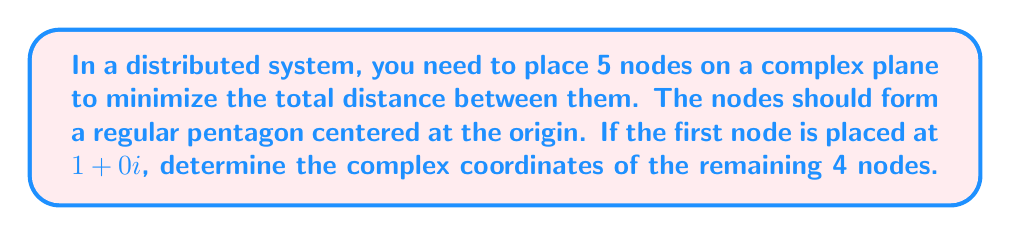Solve this math problem. To solve this problem, we'll use complex number-based optimization techniques:

1) In a regular pentagon, the angle between any two adjacent vertices from the center is $\frac{2\pi}{5}$ radians.

2) We can represent rotations in the complex plane using the formula:
   $$z_n = z_1 \cdot e^{i\frac{2\pi n}{5}}$$
   where $z_1$ is the first node, and $n$ is the node number (0 to 4).

3) Given $z_1 = 1+0i$, we can calculate the remaining nodes:

   For $n = 1$ (already given): $z_1 = 1+0i$
   
   For $n = 2$: $z_2 = (1+0i) \cdot e^{i\frac{2\pi \cdot 1}{5}} = e^{i\frac{2\pi}{5}}$
   
   For $n = 3$: $z_3 = (1+0i) \cdot e^{i\frac{2\pi \cdot 2}{5}} = e^{i\frac{4\pi}{5}}$
   
   For $n = 4$: $z_4 = (1+0i) \cdot e^{i\frac{2\pi \cdot 3}{5}} = e^{i\frac{6\pi}{5}}$
   
   For $n = 5$: $z_5 = (1+0i) \cdot e^{i\frac{2\pi \cdot 4}{5}} = e^{i\frac{8\pi}{5}}$

4) To express these in rectangular form $(a+bi)$, we use Euler's formula:
   $$e^{ix} = \cos x + i\sin x$$

   $z_2 = \cos(\frac{2\pi}{5}) + i\sin(\frac{2\pi}{5})$
   
   $z_3 = \cos(\frac{4\pi}{5}) + i\sin(\frac{4\pi}{5})$
   
   $z_4 = \cos(\frac{6\pi}{5}) + i\sin(\frac{6\pi}{5})$
   
   $z_5 = \cos(\frac{8\pi}{5}) + i\sin(\frac{8\pi}{5})$

5) Calculating these values:

   $z_2 \approx 0.309 + 0.951i$
   
   $z_3 \approx -0.809 + 0.588i$
   
   $z_4 \approx -0.809 - 0.588i$
   
   $z_5 \approx 0.309 - 0.951i$

This placement ensures optimal distribution of nodes in the complex plane, minimizing the total distance between them.
Answer: The complex coordinates of the remaining 4 nodes are:

$z_2 \approx 0.309 + 0.951i$
$z_3 \approx -0.809 + 0.588i$
$z_4 \approx -0.809 - 0.588i$
$z_5 \approx 0.309 - 0.951i$ 